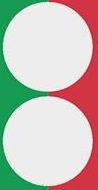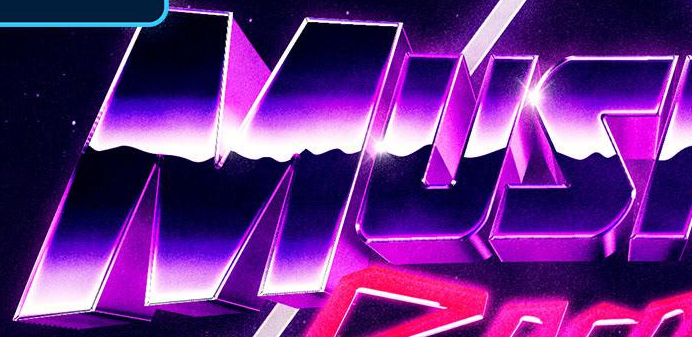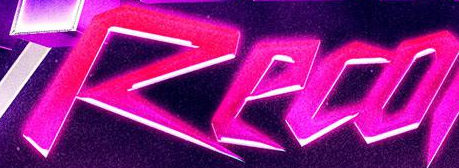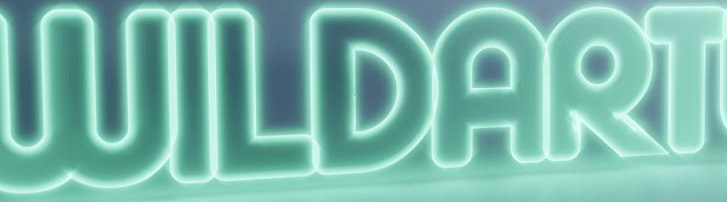Read the text content from these images in order, separated by a semicolon. :; MUS; Reco; WILDART 